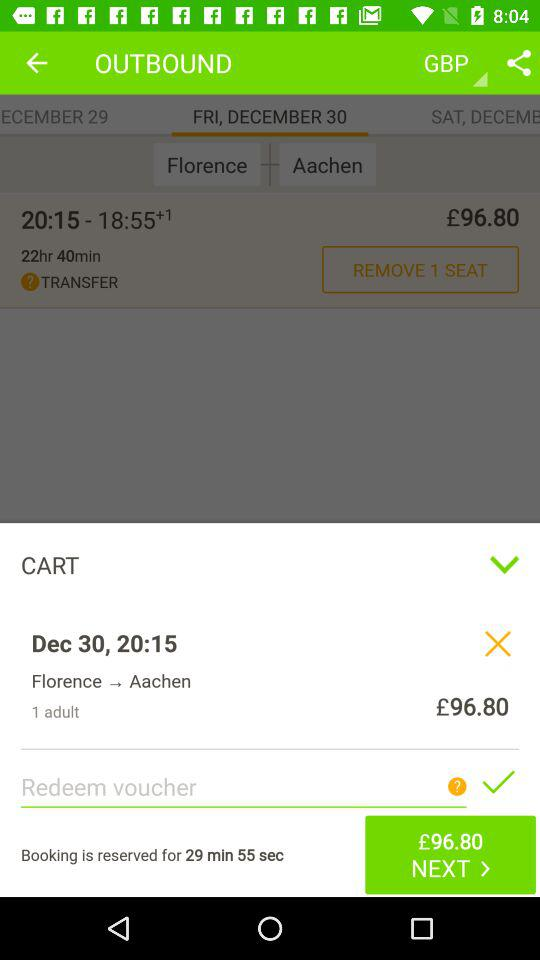What is the given price? The given price is £96.80. 